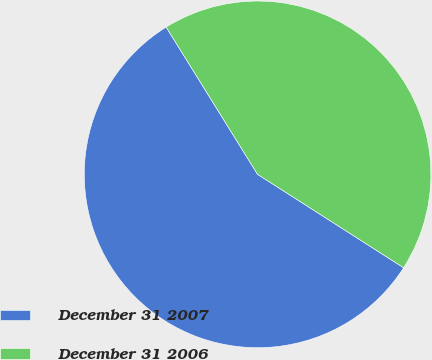Convert chart. <chart><loc_0><loc_0><loc_500><loc_500><pie_chart><fcel>December 31 2007<fcel>December 31 2006<nl><fcel>57.1%<fcel>42.9%<nl></chart> 